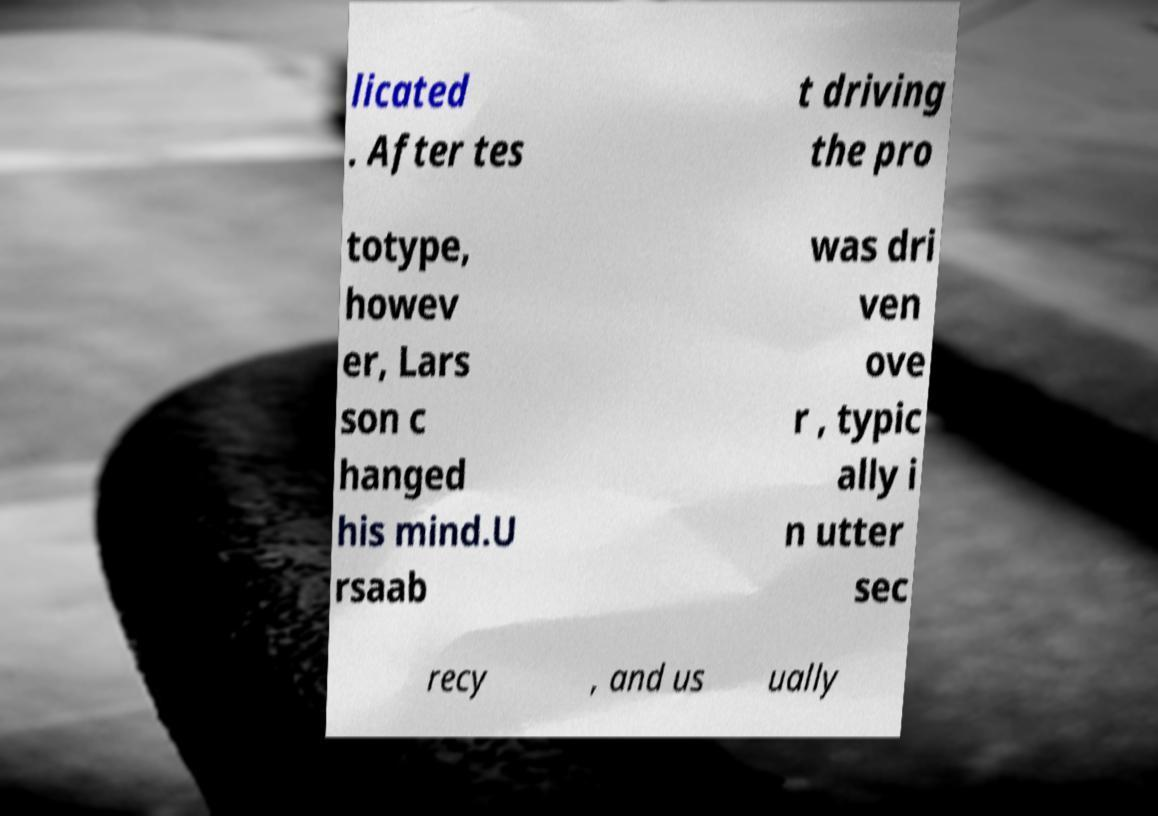Could you assist in decoding the text presented in this image and type it out clearly? licated . After tes t driving the pro totype, howev er, Lars son c hanged his mind.U rsaab was dri ven ove r , typic ally i n utter sec recy , and us ually 